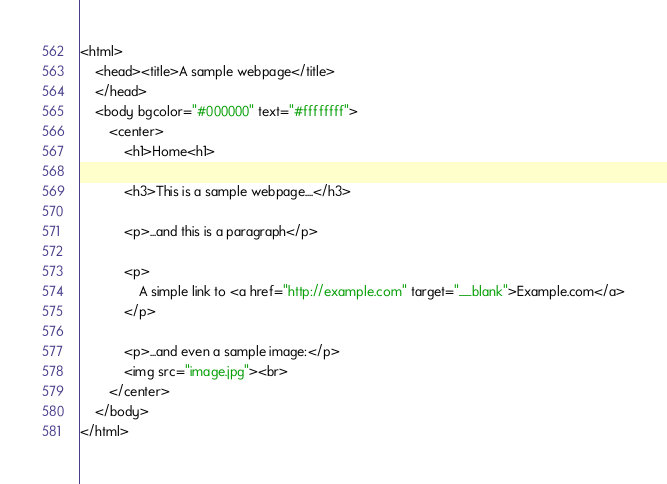<code> <loc_0><loc_0><loc_500><loc_500><_HTML_><html>
	<head><title>A sample webpage</title>
	</head>
	<body bgcolor="#000000" text="#ffffffff">
		<center>
			<h1>Home<h1>

			<h3>This is a sample webpage....</h3>

			<p>...and this is a paragraph</p>

			<p>
				A simple link to <a href="http://example.com" target="__blank">Example.com</a>
			</p>

			<p>...and even a sample image:</p>
			<img src="image.jpg"><br>
		</center>
	</body>
</html>
</code> 